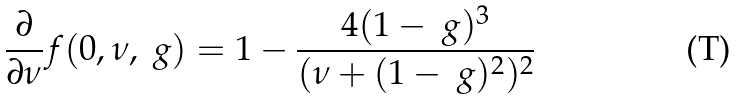<formula> <loc_0><loc_0><loc_500><loc_500>\frac { \partial } { \partial \nu } f ( 0 , \nu , \ g ) = 1 - \frac { 4 ( 1 - \ g ) ^ { 3 } } { ( \nu + ( 1 - \ g ) ^ { 2 } ) ^ { 2 } }</formula> 